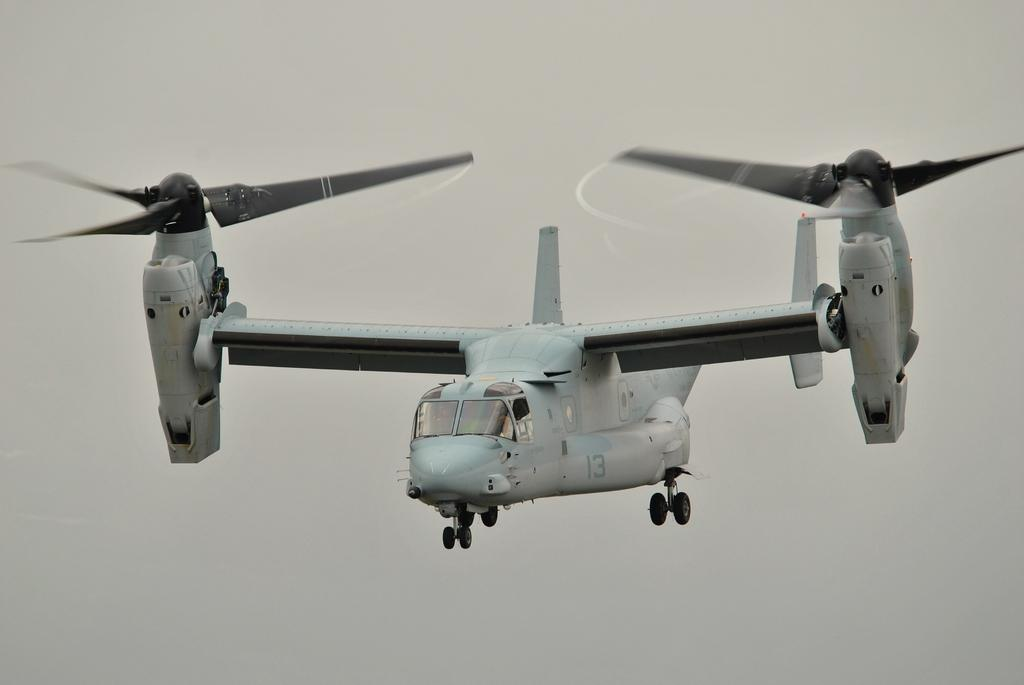What is the main subject of the image? The main subject of the image is a plane. What is the plane doing in the image? The plane is flying in the air. How is this plane different from other planes? The plane is unique. What feature is common to most planes? The plane has wings. What is attached to the wings of the plane in the image? Fans are attached to the wings of the plane. What day of the week is depicted in the image? The image does not depict a day of the week; it features a unique plane flying in the air with fans attached to its wings. Can you see a whip being used by the plane in the image? There is no whip present in the image, and the plane is not using any such object. 